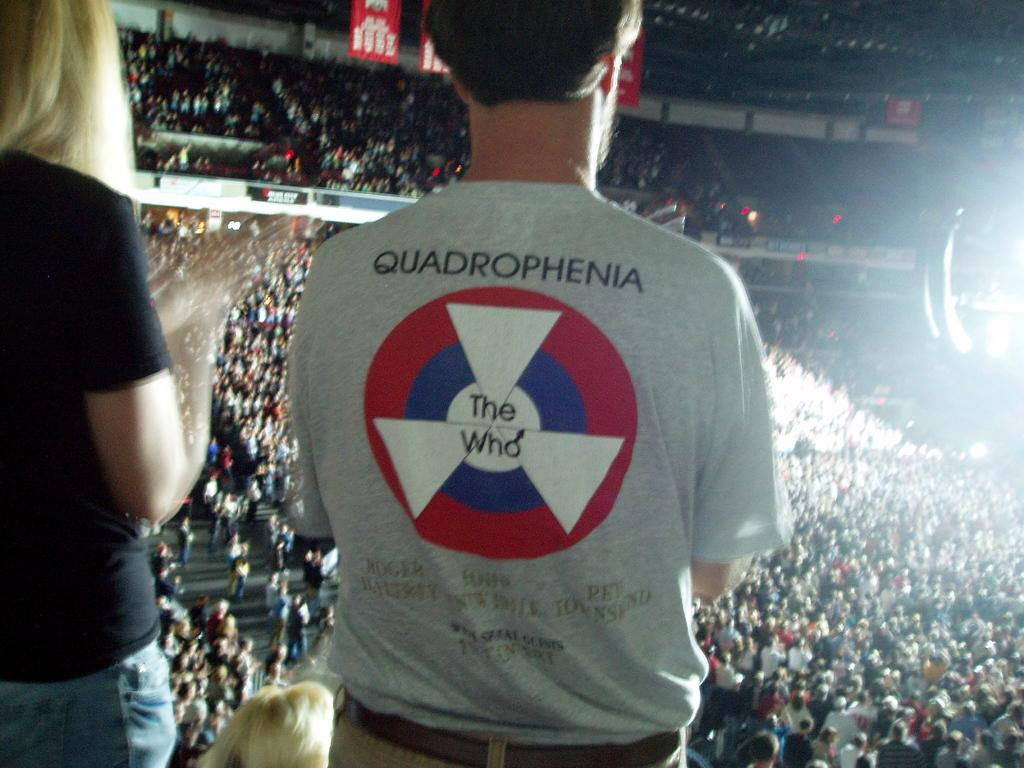<image>
Present a compact description of the photo's key features. Many concert goers at The Who concert standing up. 